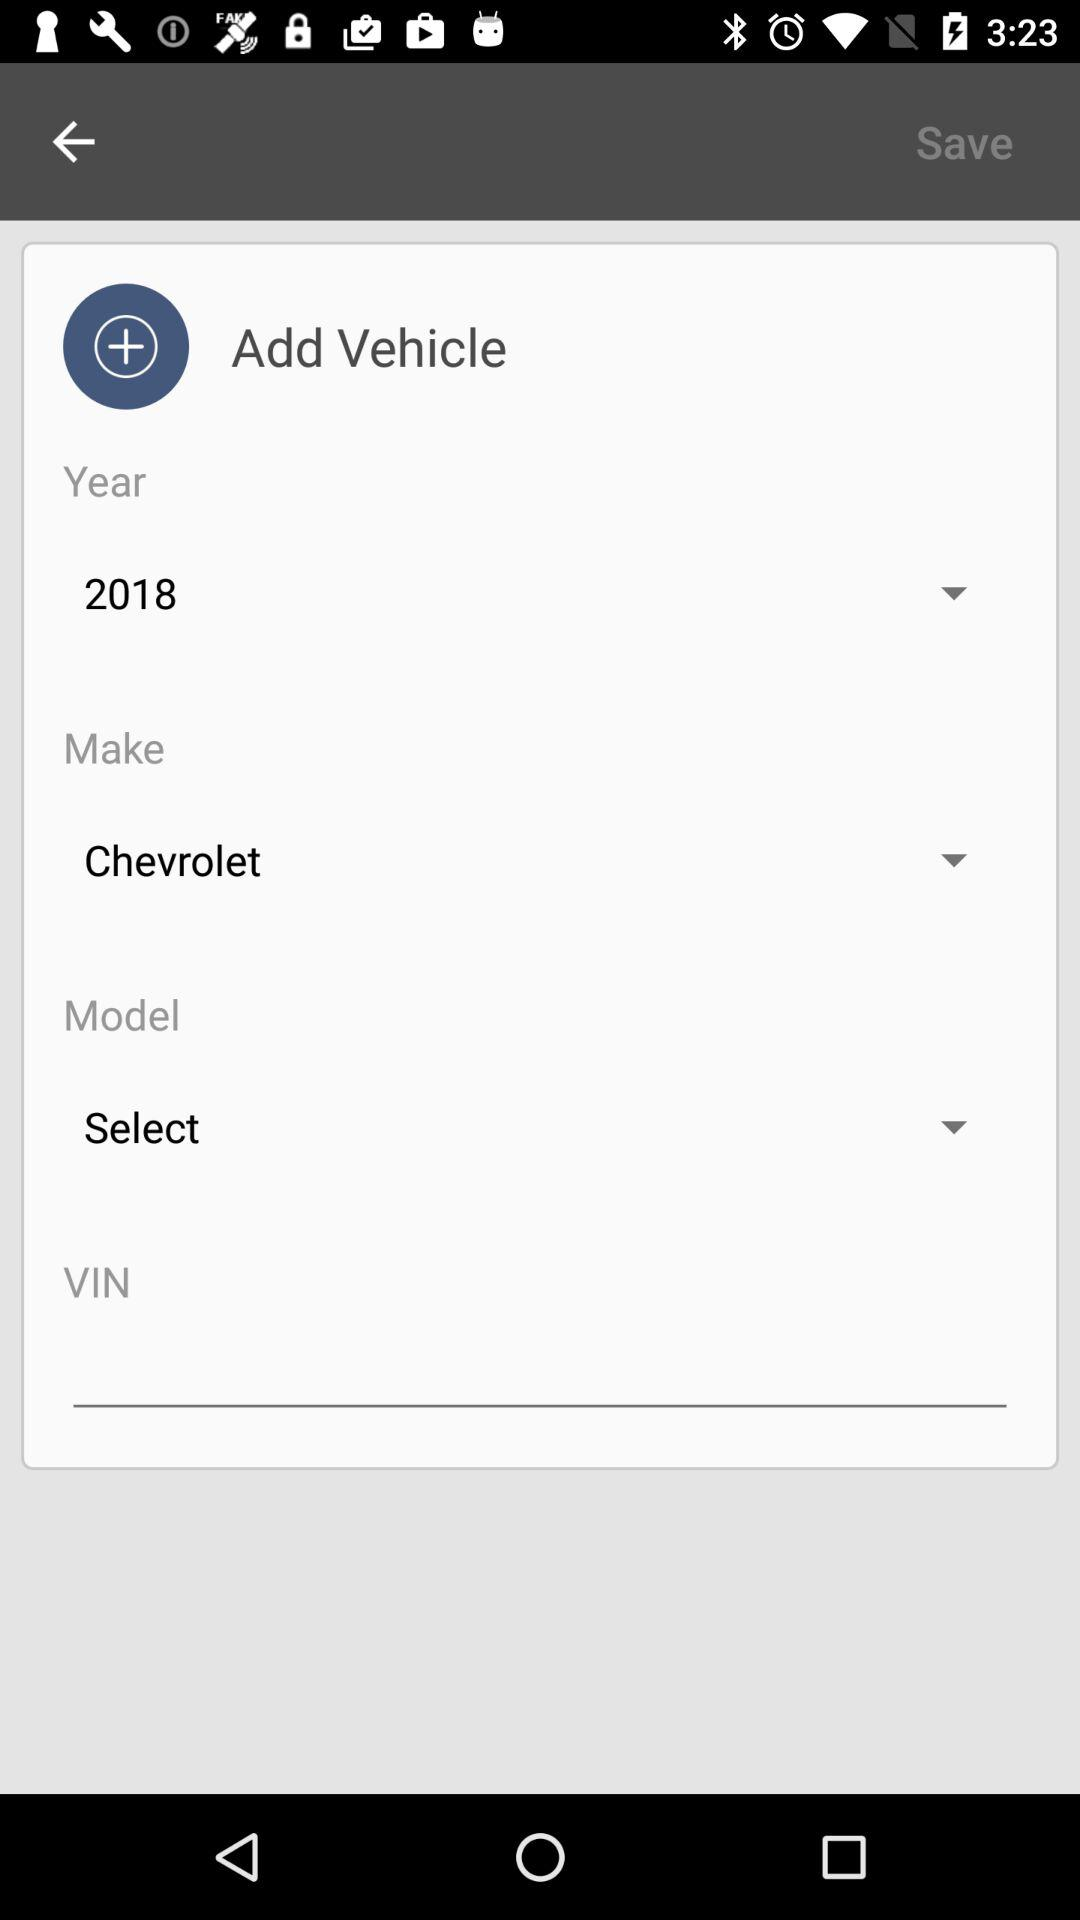How many numbers are in the VIN?
When the provided information is insufficient, respond with <no answer>. <no answer> 